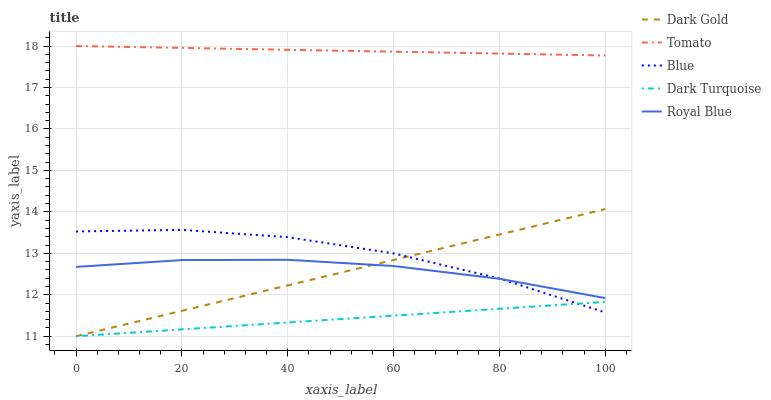Does Blue have the minimum area under the curve?
Answer yes or no. No. Does Blue have the maximum area under the curve?
Answer yes or no. No. Is Royal Blue the smoothest?
Answer yes or no. No. Is Royal Blue the roughest?
Answer yes or no. No. Does Blue have the lowest value?
Answer yes or no. No. Does Blue have the highest value?
Answer yes or no. No. Is Dark Turquoise less than Tomato?
Answer yes or no. Yes. Is Tomato greater than Blue?
Answer yes or no. Yes. Does Dark Turquoise intersect Tomato?
Answer yes or no. No. 